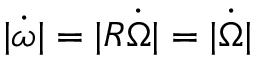Convert formula to latex. <formula><loc_0><loc_0><loc_500><loc_500>| \dot { \omega } | = | R \dot { \Omega } | = | \dot { \Omega } |</formula> 